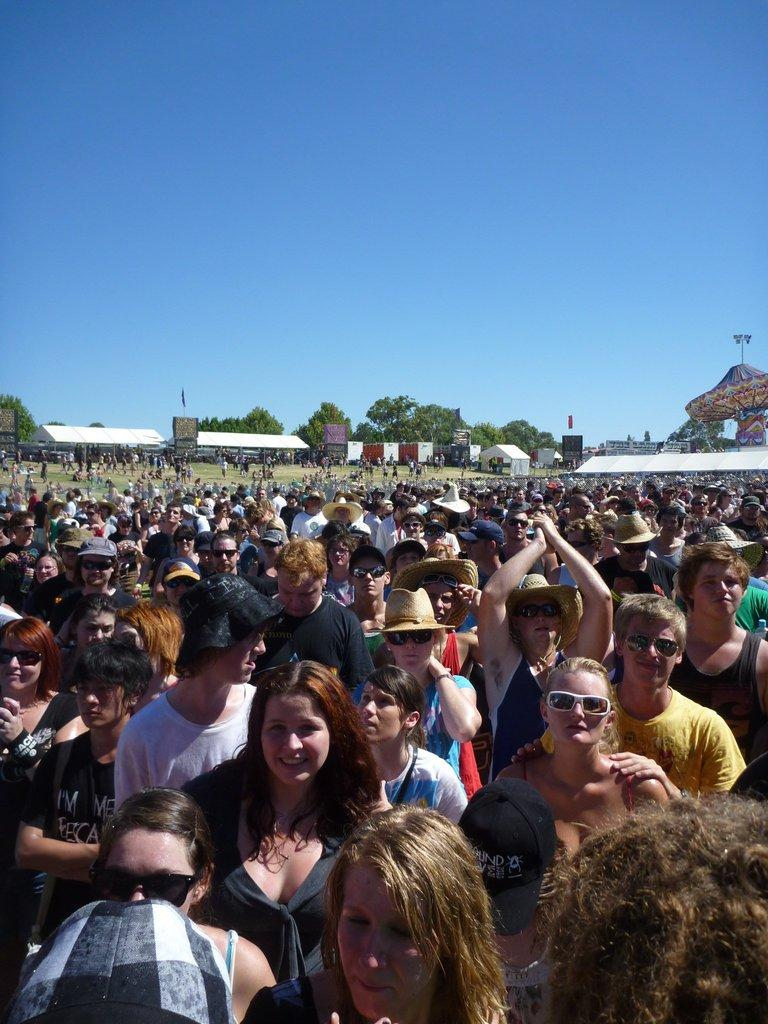What is located at the bottom of the image? There is a crowd at the bottom of the image. What can be seen in the middle of the image? Trees and shelters are visible in the middle of the image. What is visible in the background of the image? The sky is visible in the background of the image. What color is the bedroom in the image? There is no bedroom present in the image. How does the crowd hear the music in the image? The image does not provide information about music or hearing; it only shows a crowd, trees, shelters, and the sky. 